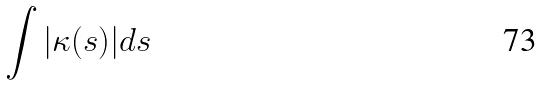Convert formula to latex. <formula><loc_0><loc_0><loc_500><loc_500>\int | \kappa ( s ) | d s</formula> 